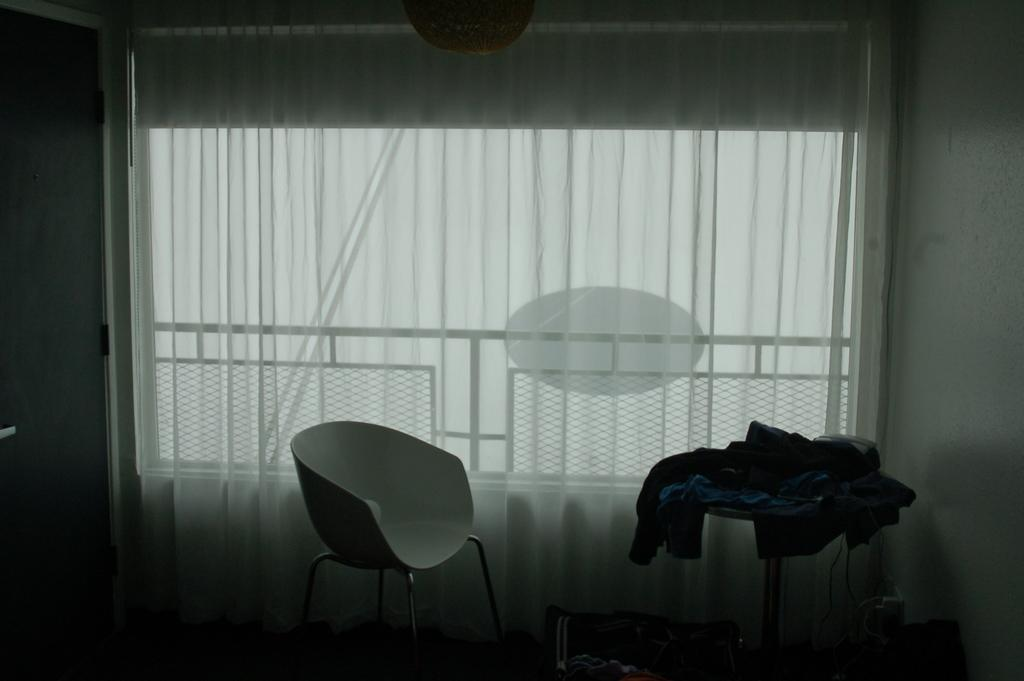What type of chair is in the image? There is a white color chair in the image. What is located in front of the chair? There is a table in front of the chair. What is placed on the table? Cloths are present on the table. What can be seen behind the chair? There is a window behind the chair. What is associated with the window? A curtain is associated with the window. How many toes are visible on the chair in the image? There are no toes visible on the chair in the image, as it is an inanimate object. 